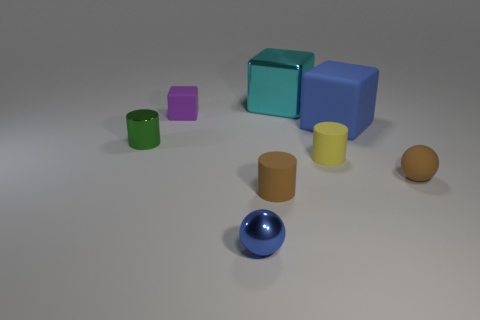Subtract all matte blocks. How many blocks are left? 1 Add 2 big cyan objects. How many objects exist? 10 Subtract all yellow cylinders. How many cylinders are left? 2 Subtract all spheres. How many objects are left? 6 Add 6 tiny cyan matte things. How many tiny cyan matte things exist? 6 Subtract 0 gray cylinders. How many objects are left? 8 Subtract all green cubes. Subtract all red spheres. How many cubes are left? 3 Subtract all tiny blue metallic spheres. Subtract all big brown cylinders. How many objects are left? 7 Add 3 small metallic cylinders. How many small metallic cylinders are left? 4 